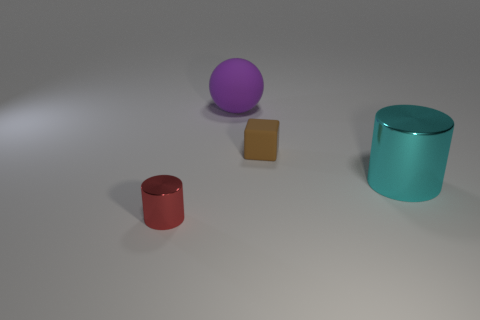Is there any particular texture or pattern visible on the surface of the objects or the ground? The objects and the ground have a matte finish with no distinct texture or pattern. The surfaces appear smooth, and the lack of any visible grain or roughness suggests a synthetic or digital rendering rather than physical materials. 